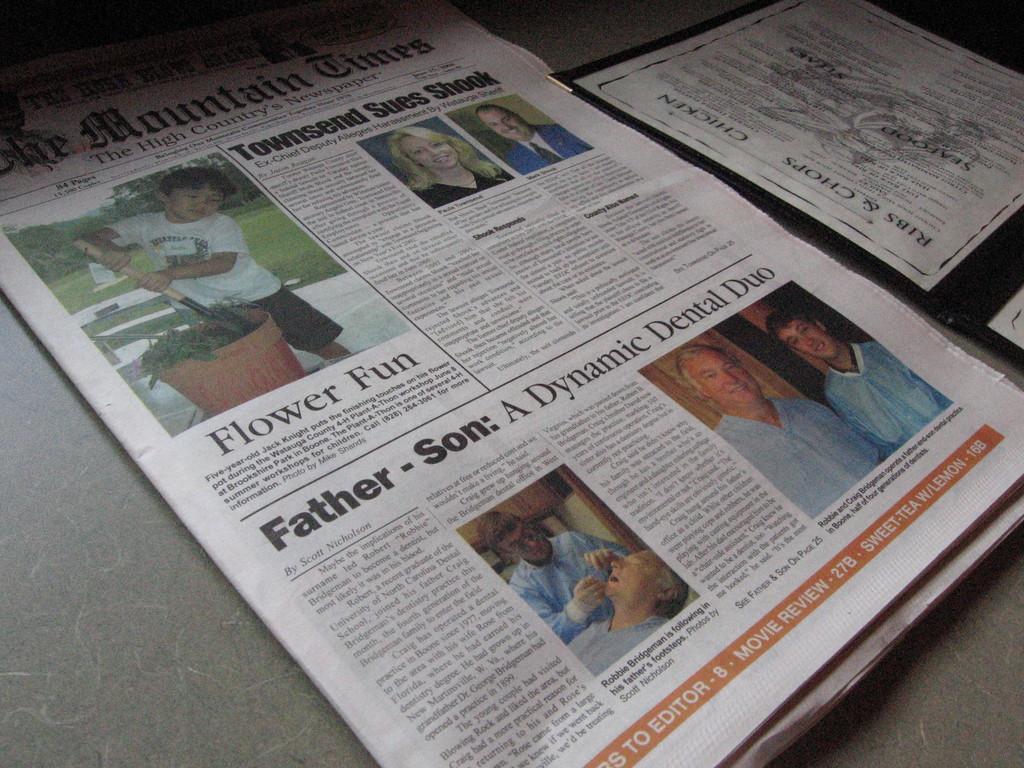What's the title of the second article?
Provide a short and direct response. Father-son: a dynamic dental duo. What is the caption just below the top left picture?
Keep it short and to the point. Flower fun. 